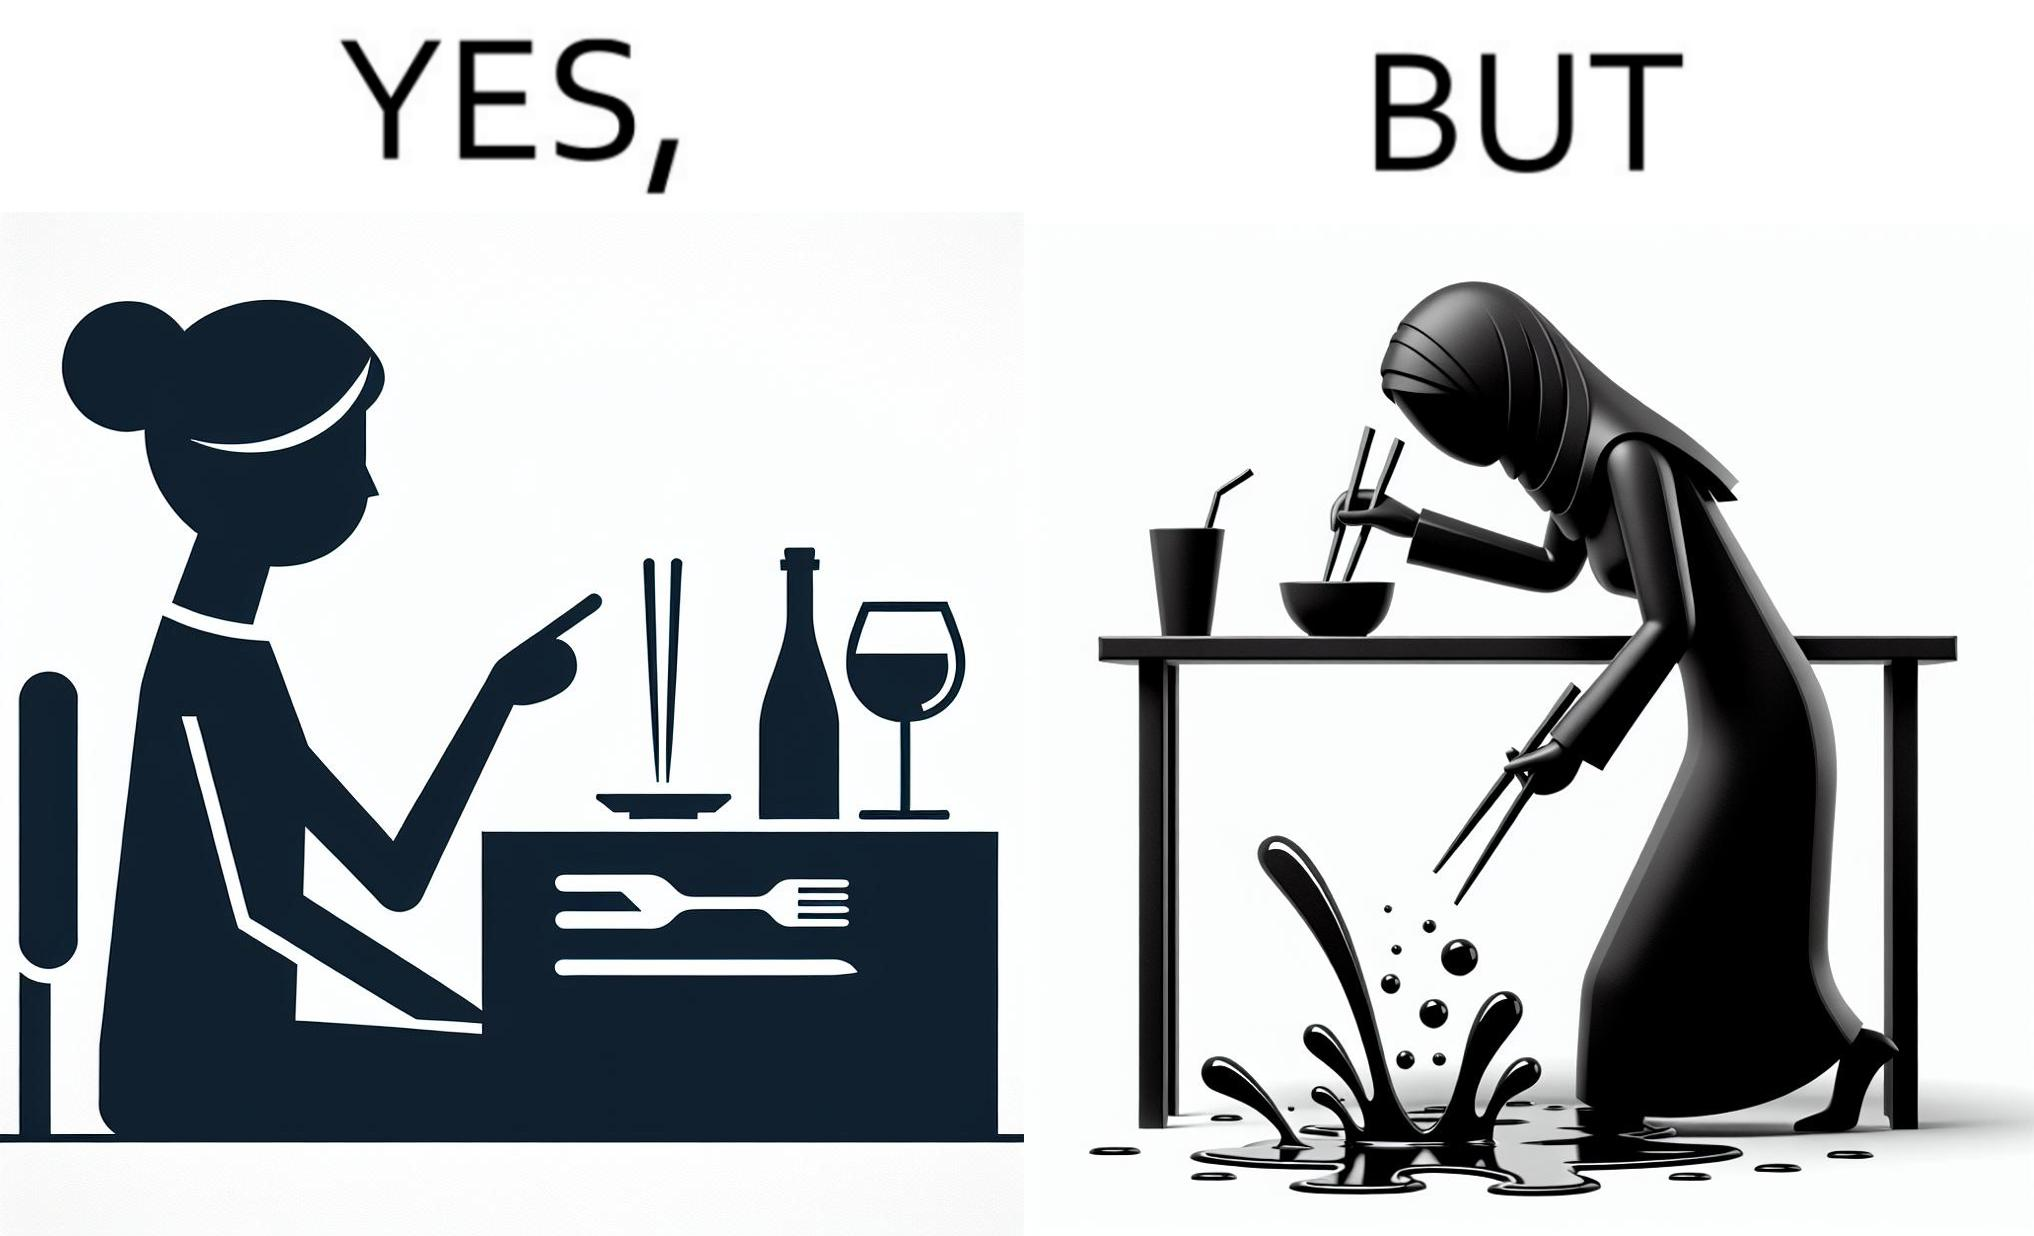What is shown in the left half versus the right half of this image? In the left part of the image: The image shows a woman sitting at a table in a restaruant pointing to chopsticks on her table. There is also a wine glass, a fork and a knief on her table. In the right part of the image: The image shows a person using chopstick to pick up food from the cup. The person is not able to handle food with chopstick well and is dropping the food around the cup on the table. 